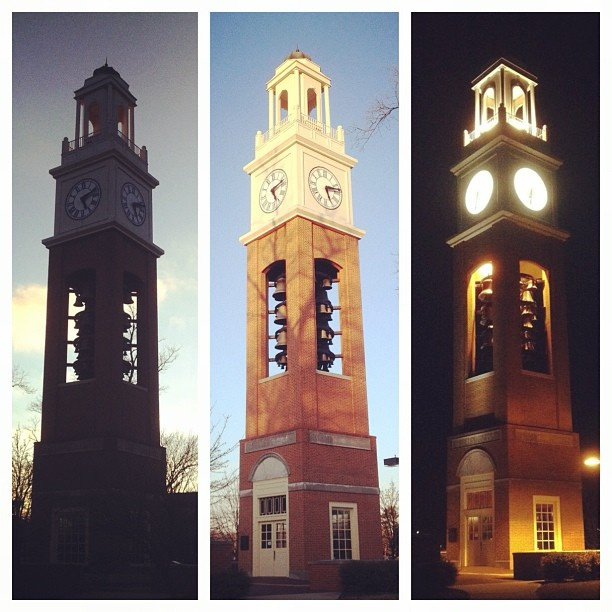Describe the objects in this image and their specific colors. I can see clock in white, tan, and beige tones, clock in white and black tones, clock in white, lightyellow, and tan tones, clock in white, tan, and beige tones, and clock in white, lightyellow, beige, and tan tones in this image. 